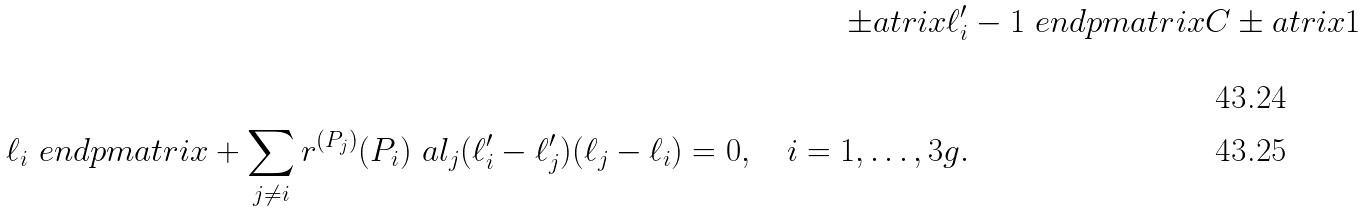Convert formula to latex. <formula><loc_0><loc_0><loc_500><loc_500>\pm a t r i x \ell ^ { \prime } _ { i } & - 1 \ e n d p m a t r i x C \pm a t r i x 1 \\ \ell _ { i } \ e n d p m a t r i x + \sum _ { j \neq i } r ^ { ( P _ { j } ) } ( P _ { i } ) \ a l _ { j } ( \ell ^ { \prime } _ { i } - \ell ^ { \prime } _ { j } ) ( \ell _ { j } - \ell _ { i } ) = 0 , \quad i = 1 , \dots , 3 g .</formula> 